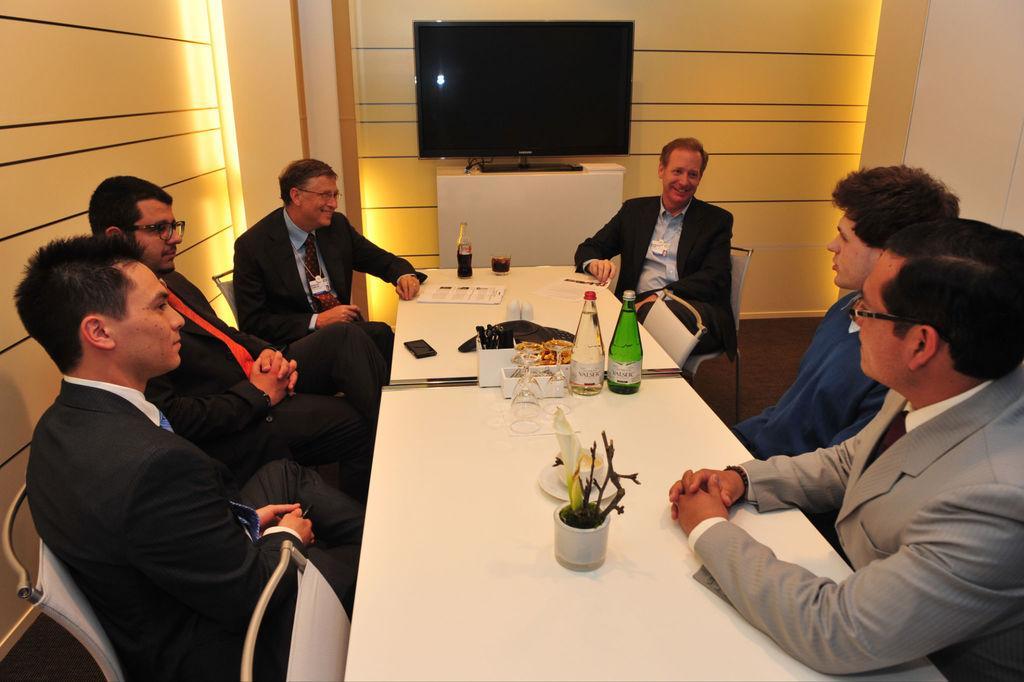Could you give a brief overview of what you see in this image? These persons are sitting on a chair. In-front of this person's there is a table, on this table there are bottles, glass, mobile, plant, plate holder and paper. Far there is a table, on this table there is a television. These four persons wore black suit. 